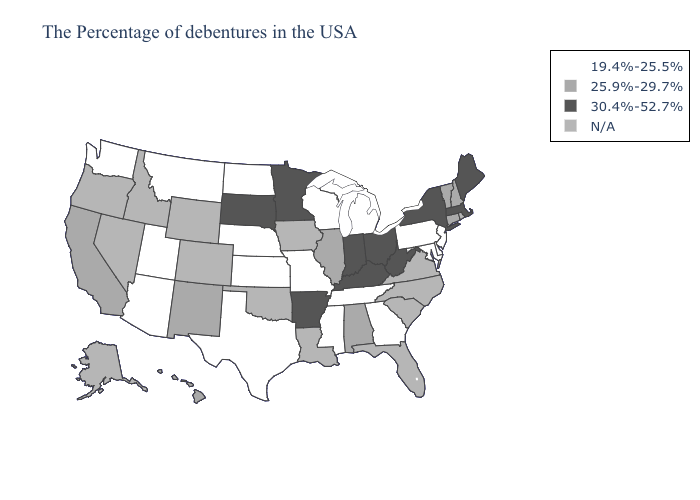What is the lowest value in states that border Massachusetts?
Answer briefly. 25.9%-29.7%. Name the states that have a value in the range N/A?
Short answer required. Rhode Island, Virginia, North Carolina, South Carolina, Florida, Louisiana, Iowa, Oklahoma, Wyoming, Colorado, Idaho, Nevada, Oregon, Alaska. Does North Dakota have the highest value in the MidWest?
Be succinct. No. What is the value of Montana?
Be succinct. 19.4%-25.5%. What is the value of Oregon?
Write a very short answer. N/A. What is the highest value in states that border Nevada?
Keep it brief. 25.9%-29.7%. Which states have the highest value in the USA?
Write a very short answer. Maine, Massachusetts, New York, West Virginia, Ohio, Kentucky, Indiana, Arkansas, Minnesota, South Dakota. Which states have the highest value in the USA?
Answer briefly. Maine, Massachusetts, New York, West Virginia, Ohio, Kentucky, Indiana, Arkansas, Minnesota, South Dakota. Name the states that have a value in the range 25.9%-29.7%?
Answer briefly. New Hampshire, Vermont, Connecticut, Alabama, Illinois, New Mexico, California, Hawaii. Among the states that border Ohio , which have the lowest value?
Answer briefly. Pennsylvania, Michigan. Does Michigan have the highest value in the MidWest?
Write a very short answer. No. What is the value of Oklahoma?
Concise answer only. N/A. What is the highest value in the West ?
Be succinct. 25.9%-29.7%. 